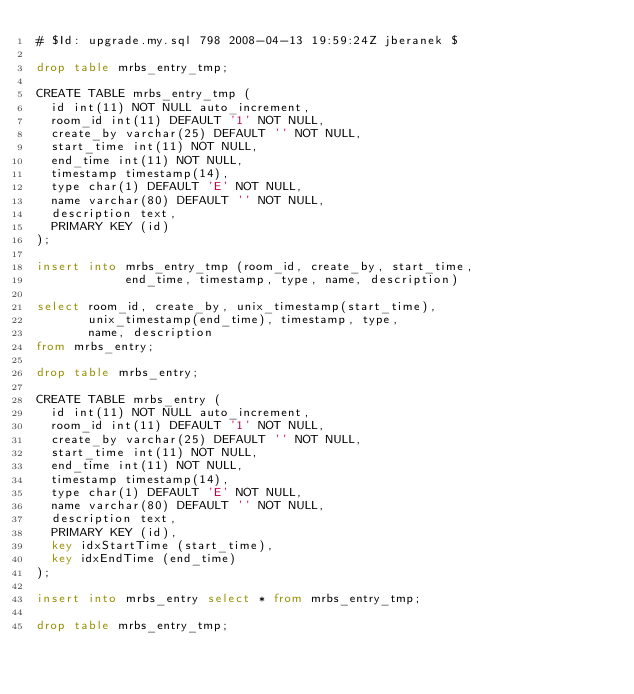Convert code to text. <code><loc_0><loc_0><loc_500><loc_500><_SQL_># $Id: upgrade.my.sql 798 2008-04-13 19:59:24Z jberanek $

drop table mrbs_entry_tmp;

CREATE TABLE mrbs_entry_tmp (
  id int(11) NOT NULL auto_increment,
  room_id int(11) DEFAULT '1' NOT NULL,
  create_by varchar(25) DEFAULT '' NOT NULL,
  start_time int(11) NOT NULL,
  end_time int(11) NOT NULL,
  timestamp timestamp(14),
  type char(1) DEFAULT 'E' NOT NULL,
  name varchar(80) DEFAULT '' NOT NULL,
  description text,
  PRIMARY KEY (id)
);

insert into mrbs_entry_tmp (room_id, create_by, start_time,
            end_time, timestamp, type, name, description)

select room_id, create_by, unix_timestamp(start_time),
       unix_timestamp(end_time), timestamp, type,
       name, description
from mrbs_entry;

drop table mrbs_entry;

CREATE TABLE mrbs_entry (
  id int(11) NOT NULL auto_increment,
  room_id int(11) DEFAULT '1' NOT NULL,
  create_by varchar(25) DEFAULT '' NOT NULL,
  start_time int(11) NOT NULL,
  end_time int(11) NOT NULL,
  timestamp timestamp(14),
  type char(1) DEFAULT 'E' NOT NULL,
  name varchar(80) DEFAULT '' NOT NULL,
  description text,
  PRIMARY KEY (id),
  key idxStartTime (start_time),
  key idxEndTime (end_time)
);

insert into mrbs_entry select * from mrbs_entry_tmp;

drop table mrbs_entry_tmp;
</code> 